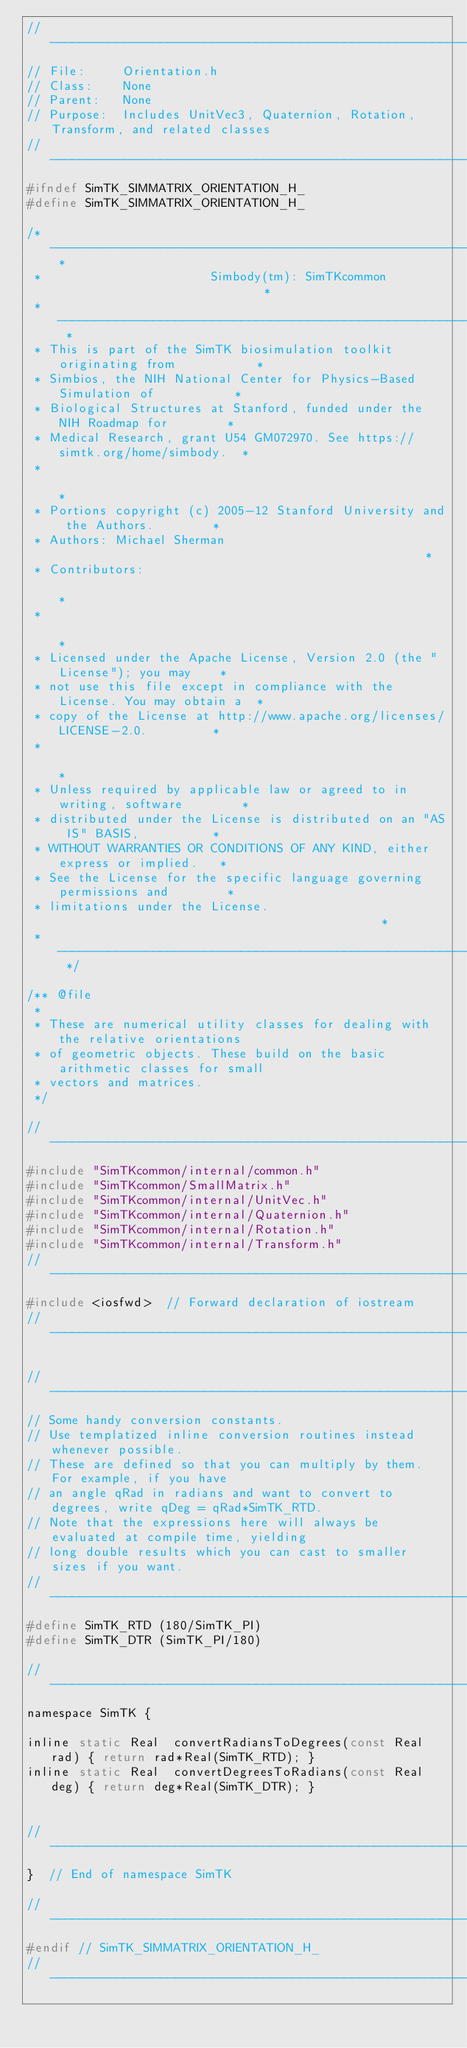<code> <loc_0><loc_0><loc_500><loc_500><_C_>//-----------------------------------------------------------------------------
// File:     Orientation.h
// Class:    None 
// Parent:   None
// Purpose:  Includes UnitVec3, Quaternion, Rotation, Transform, and related classes
//-----------------------------------------------------------------------------
#ifndef SimTK_SIMMATRIX_ORIENTATION_H_
#define SimTK_SIMMATRIX_ORIENTATION_H_

/* -------------------------------------------------------------------------- *
 *                       Simbody(tm): SimTKcommon                             *
 * -------------------------------------------------------------------------- *
 * This is part of the SimTK biosimulation toolkit originating from           *
 * Simbios, the NIH National Center for Physics-Based Simulation of           *
 * Biological Structures at Stanford, funded under the NIH Roadmap for        *
 * Medical Research, grant U54 GM072970. See https://simtk.org/home/simbody.  *
 *                                                                            *
 * Portions copyright (c) 2005-12 Stanford University and the Authors.        *
 * Authors: Michael Sherman                                                   *
 * Contributors:                                                              *
 *                                                                            *
 * Licensed under the Apache License, Version 2.0 (the "License"); you may    *
 * not use this file except in compliance with the License. You may obtain a  *
 * copy of the License at http://www.apache.org/licenses/LICENSE-2.0.         *
 *                                                                            *
 * Unless required by applicable law or agreed to in writing, software        *
 * distributed under the License is distributed on an "AS IS" BASIS,          *
 * WITHOUT WARRANTIES OR CONDITIONS OF ANY KIND, either express or implied.   *
 * See the License for the specific language governing permissions and        *
 * limitations under the License.                                             *
 * -------------------------------------------------------------------------- */

/** @file
 *
 * These are numerical utility classes for dealing with the relative orientations
 * of geometric objects. These build on the basic arithmetic classes for small
 * vectors and matrices.
 */

//-----------------------------------------------------------------------------
#include "SimTKcommon/internal/common.h"
#include "SimTKcommon/SmallMatrix.h"
#include "SimTKcommon/internal/UnitVec.h"
#include "SimTKcommon/internal/Quaternion.h"
#include "SimTKcommon/internal/Rotation.h"
#include "SimTKcommon/internal/Transform.h"
//-----------------------------------------------------------------------------
#include <iosfwd>  // Forward declaration of iostream
//-----------------------------------------------------------------------------

//-----------------------------------------------------------------------------
// Some handy conversion constants. 
// Use templatized inline conversion routines instead whenever possible.
// These are defined so that you can multiply by them. For example, if you have
// an angle qRad in radians and want to convert to degrees, write qDeg = qRad*SimTK_RTD.
// Note that the expressions here will always be evaluated at compile time, yielding
// long double results which you can cast to smaller sizes if you want.
//-----------------------------------------------------------------------------
#define SimTK_RTD (180/SimTK_PI)
#define SimTK_DTR (SimTK_PI/180)

//-----------------------------------------------------------------------------
namespace SimTK {

inline static Real  convertRadiansToDegrees(const Real rad) { return rad*Real(SimTK_RTD); }
inline static Real  convertDegreesToRadians(const Real deg) { return deg*Real(SimTK_DTR); }


//------------------------------------------------------------------------------
}  // End of namespace SimTK

//--------------------------------------------------------------------------
#endif // SimTK_SIMMATRIX_ORIENTATION_H_
//--------------------------------------------------------------------------
</code> 